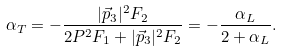<formula> <loc_0><loc_0><loc_500><loc_500>\alpha _ { T } = - \frac { | \vec { p } _ { 3 } | ^ { 2 } F _ { 2 } } { 2 P ^ { 2 } F _ { 1 } + | \vec { p } _ { 3 } | ^ { 2 } F _ { 2 } } = - \frac { \alpha _ { L } } { 2 + \alpha _ { L } } .</formula> 